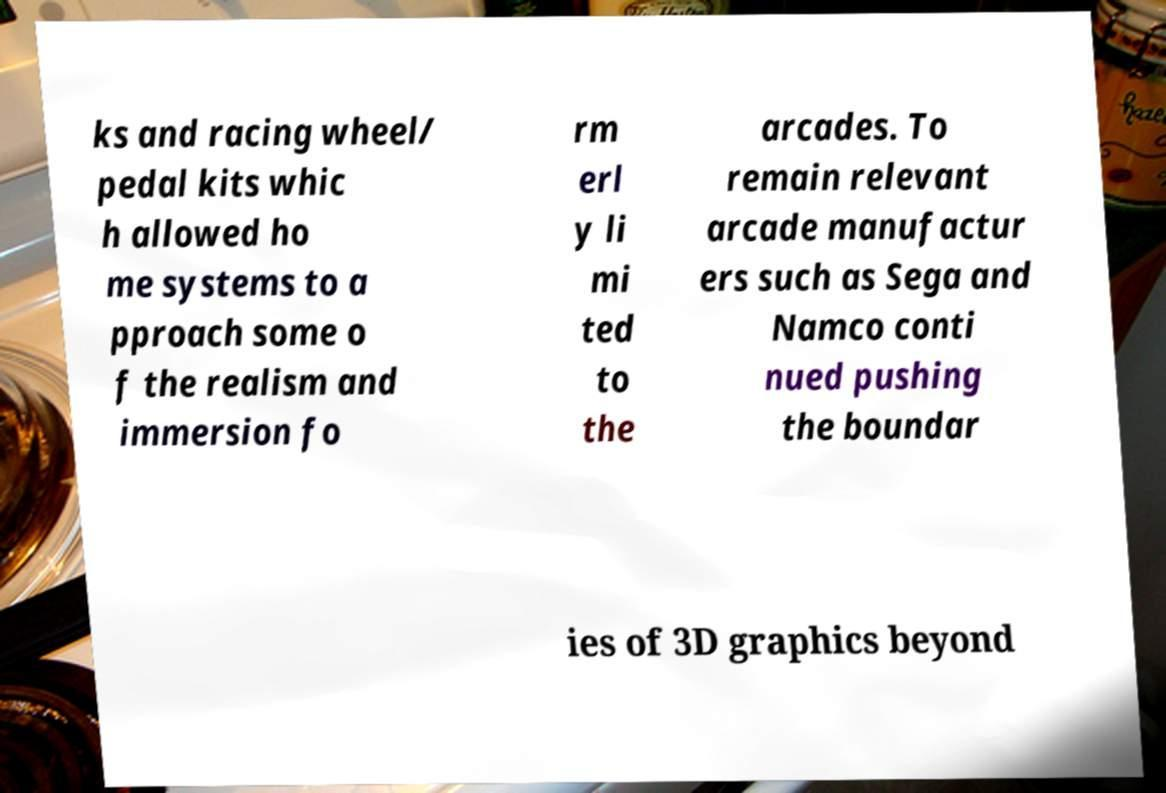I need the written content from this picture converted into text. Can you do that? ks and racing wheel/ pedal kits whic h allowed ho me systems to a pproach some o f the realism and immersion fo rm erl y li mi ted to the arcades. To remain relevant arcade manufactur ers such as Sega and Namco conti nued pushing the boundar ies of 3D graphics beyond 